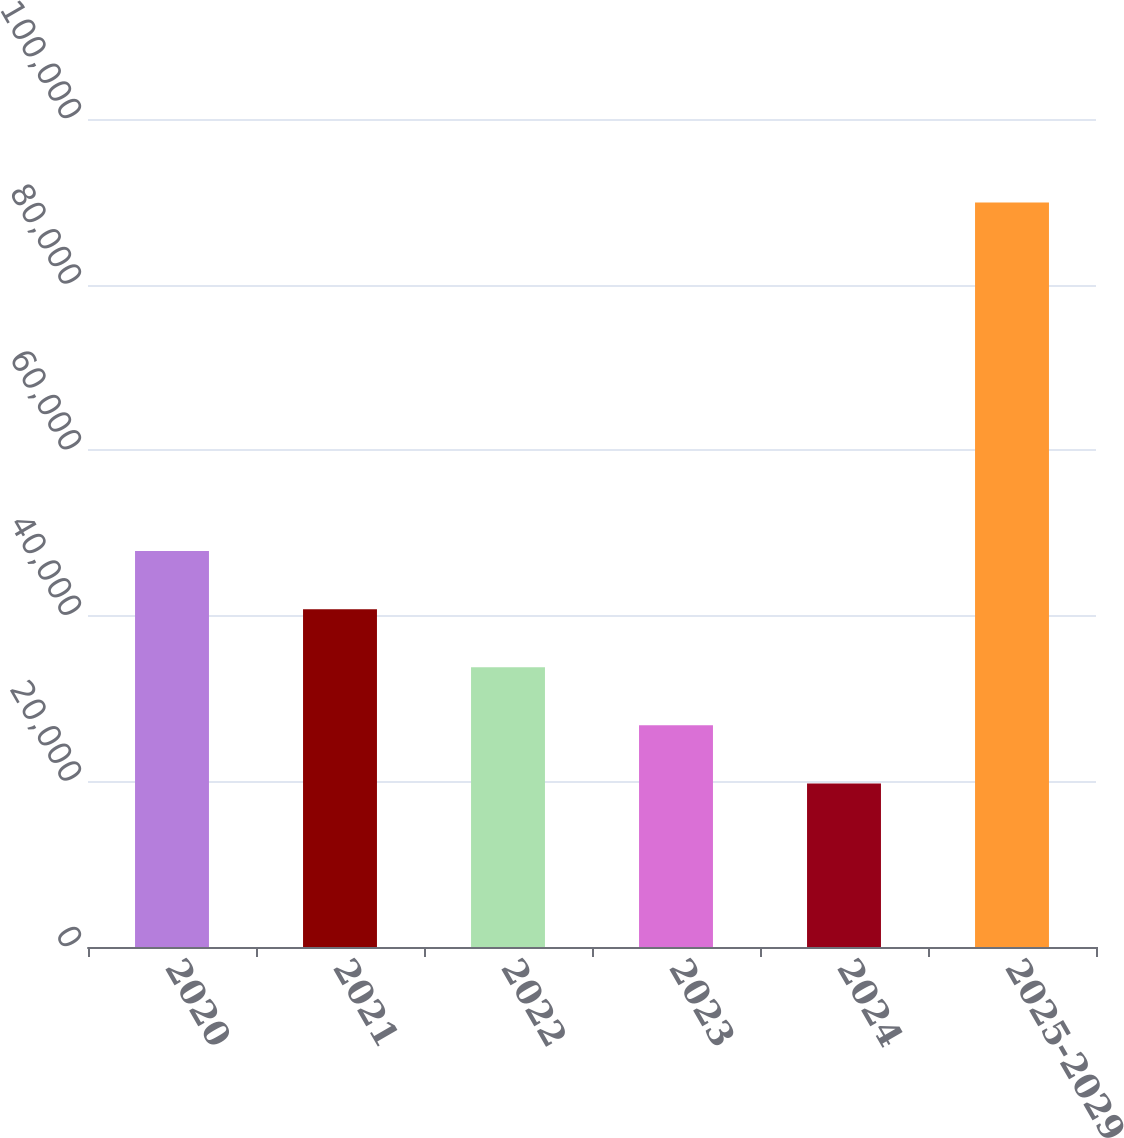<chart> <loc_0><loc_0><loc_500><loc_500><bar_chart><fcel>2020<fcel>2021<fcel>2022<fcel>2023<fcel>2024<fcel>2025-2029<nl><fcel>47820.4<fcel>40802.8<fcel>33785.2<fcel>26767.6<fcel>19750<fcel>89926<nl></chart> 